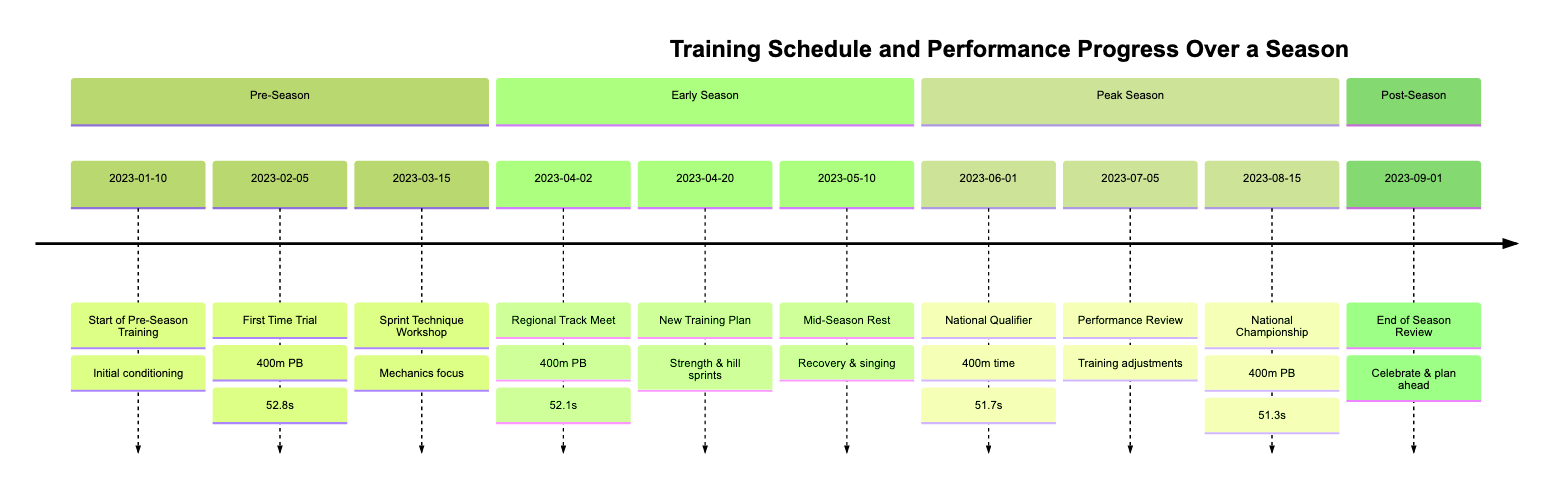What event occurred on January 10, 2023? The event listed for that date is the "Start of Pre-Season Training." This information is directly stated in the timeline as the first element in the Pre-Season section.
Answer: Start of Pre-Season Training What personal best was set at the First Time Trial? The personal best established during the First Time Trial on February 5, 2023, is specified as 52.8 seconds for the 400m. This is mentioned in the description of that event.
Answer: 52.8 seconds How many events are listed in the Peak Season section? The Peak Season section contains three events: National Qualifier, Performance Review, and National Championship. Counting these events confirms the total.
Answer: 3 What training improvement was implemented on April 20, 2023? The training improvement mentioned on April 20 is the introduction of "strength training and hill sprints" into the routine. This is highlighted in the description of that date's event in the Early Season section.
Answer: Strength training and hill sprints What was the personal best achieved at the National Championship? The personal best indicated for the event at the National Championship on August 15, 2023, is 51.3 seconds in the 400m. This figure is noted within the description of that event.
Answer: 51.3 seconds Which event marked the end of the season? The event marking the end of the season is identified as the "End of Season Review" on September 1, 2023, which is explicitly stated in the Post-Season section.
Answer: End of Season Review How did the training plan change mid-season? The change in training plan during the mid-season, specifically noted on May 10, included taking a week off for "recovery and vocal practice sessions." This combination of activities is detailed in that segment.
Answer: Recovery and vocal practice sessions What was the outcome of the Performance Review on July 5, 2023? The outcome mentioned for the Performance Review is an adjustment to training for "optimal peak at nationals," emphasizing a strategic focus on performance improvement. This summary captures the intent behind the review.
Answer: Adjusted training for optimal peak at nationals What was the date of the First National Qualifier? The First National Qualifier took place on June 1, 2023, as recorded in the timeline under the Peak Season section. The exact date correlates with the noted event.
Answer: June 1, 2023 